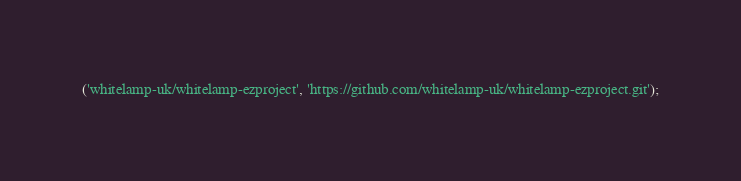<code> <loc_0><loc_0><loc_500><loc_500><_SQL_>('whitelamp-uk/whitelamp-ezproject', 'https://github.com/whitelamp-uk/whitelamp-ezproject.git');

</code> 